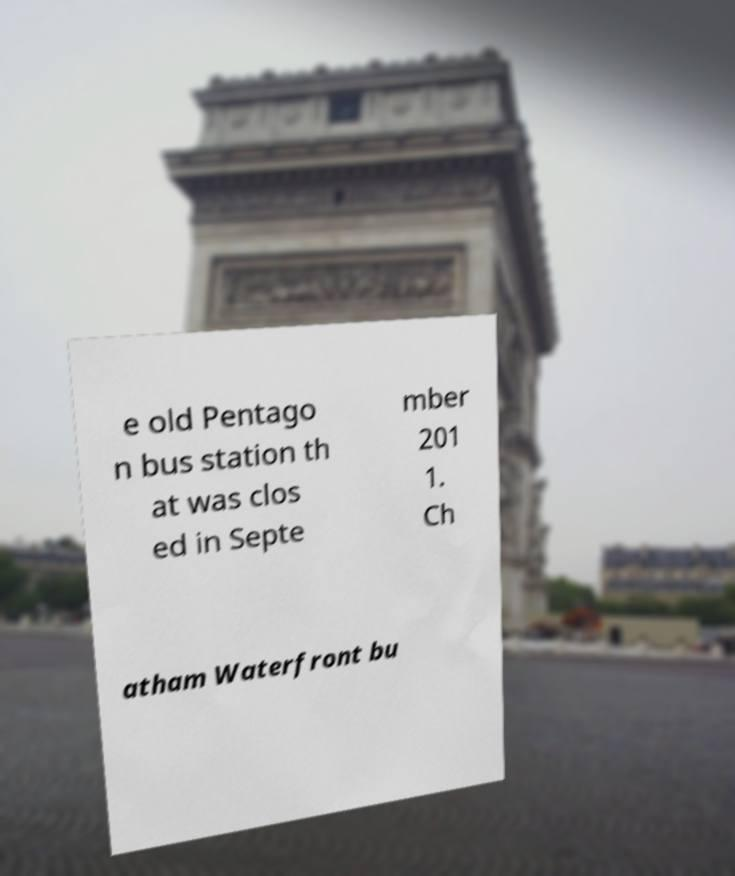Could you assist in decoding the text presented in this image and type it out clearly? e old Pentago n bus station th at was clos ed in Septe mber 201 1. Ch atham Waterfront bu 